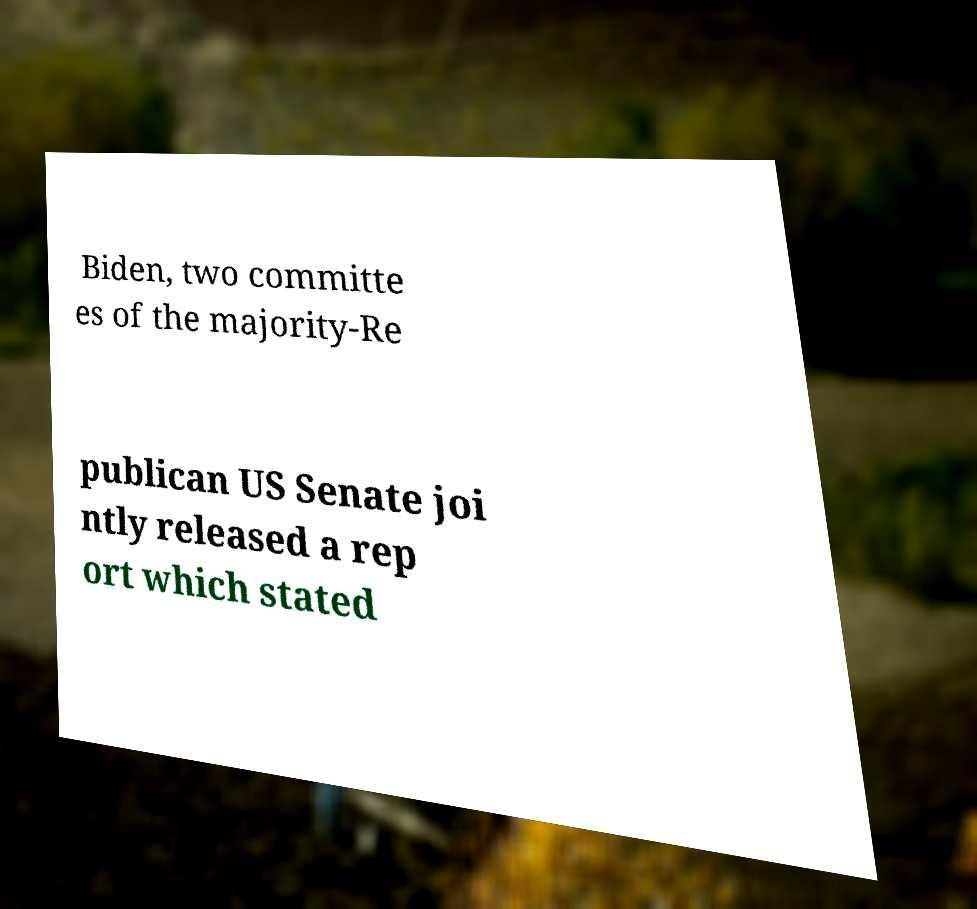Could you extract and type out the text from this image? Biden, two committe es of the majority-Re publican US Senate joi ntly released a rep ort which stated 